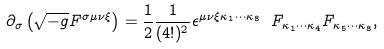<formula> <loc_0><loc_0><loc_500><loc_500>\partial _ { \sigma } \left ( \sqrt { - g } F ^ { \sigma \mu \nu \xi } \right ) = \frac { 1 } { 2 } \frac { 1 } { ( 4 ! ) ^ { 2 } } \epsilon ^ { \mu \nu \xi \kappa _ { 1 } \cdots \kappa _ { 8 } } \ F _ { \kappa _ { 1 } \cdots \kappa _ { 4 } } F _ { \kappa _ { 5 } \cdots \kappa _ { 8 } } ,</formula> 